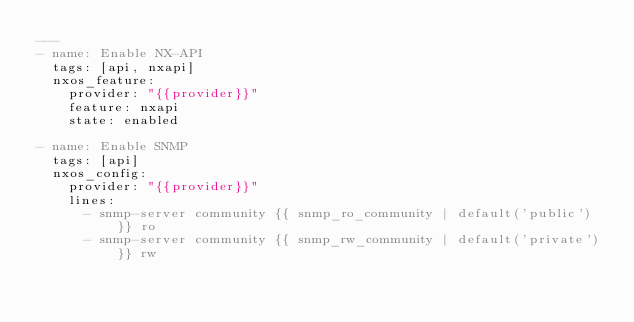<code> <loc_0><loc_0><loc_500><loc_500><_YAML_>---
- name: Enable NX-API
  tags: [api, nxapi]
  nxos_feature:
    provider: "{{provider}}"
    feature: nxapi
    state: enabled

- name: Enable SNMP
  tags: [api]
  nxos_config:
    provider: "{{provider}}"
    lines:
      - snmp-server community {{ snmp_ro_community | default('public') }} ro
      - snmp-server community {{ snmp_rw_community | default('private') }} rw
      
</code> 